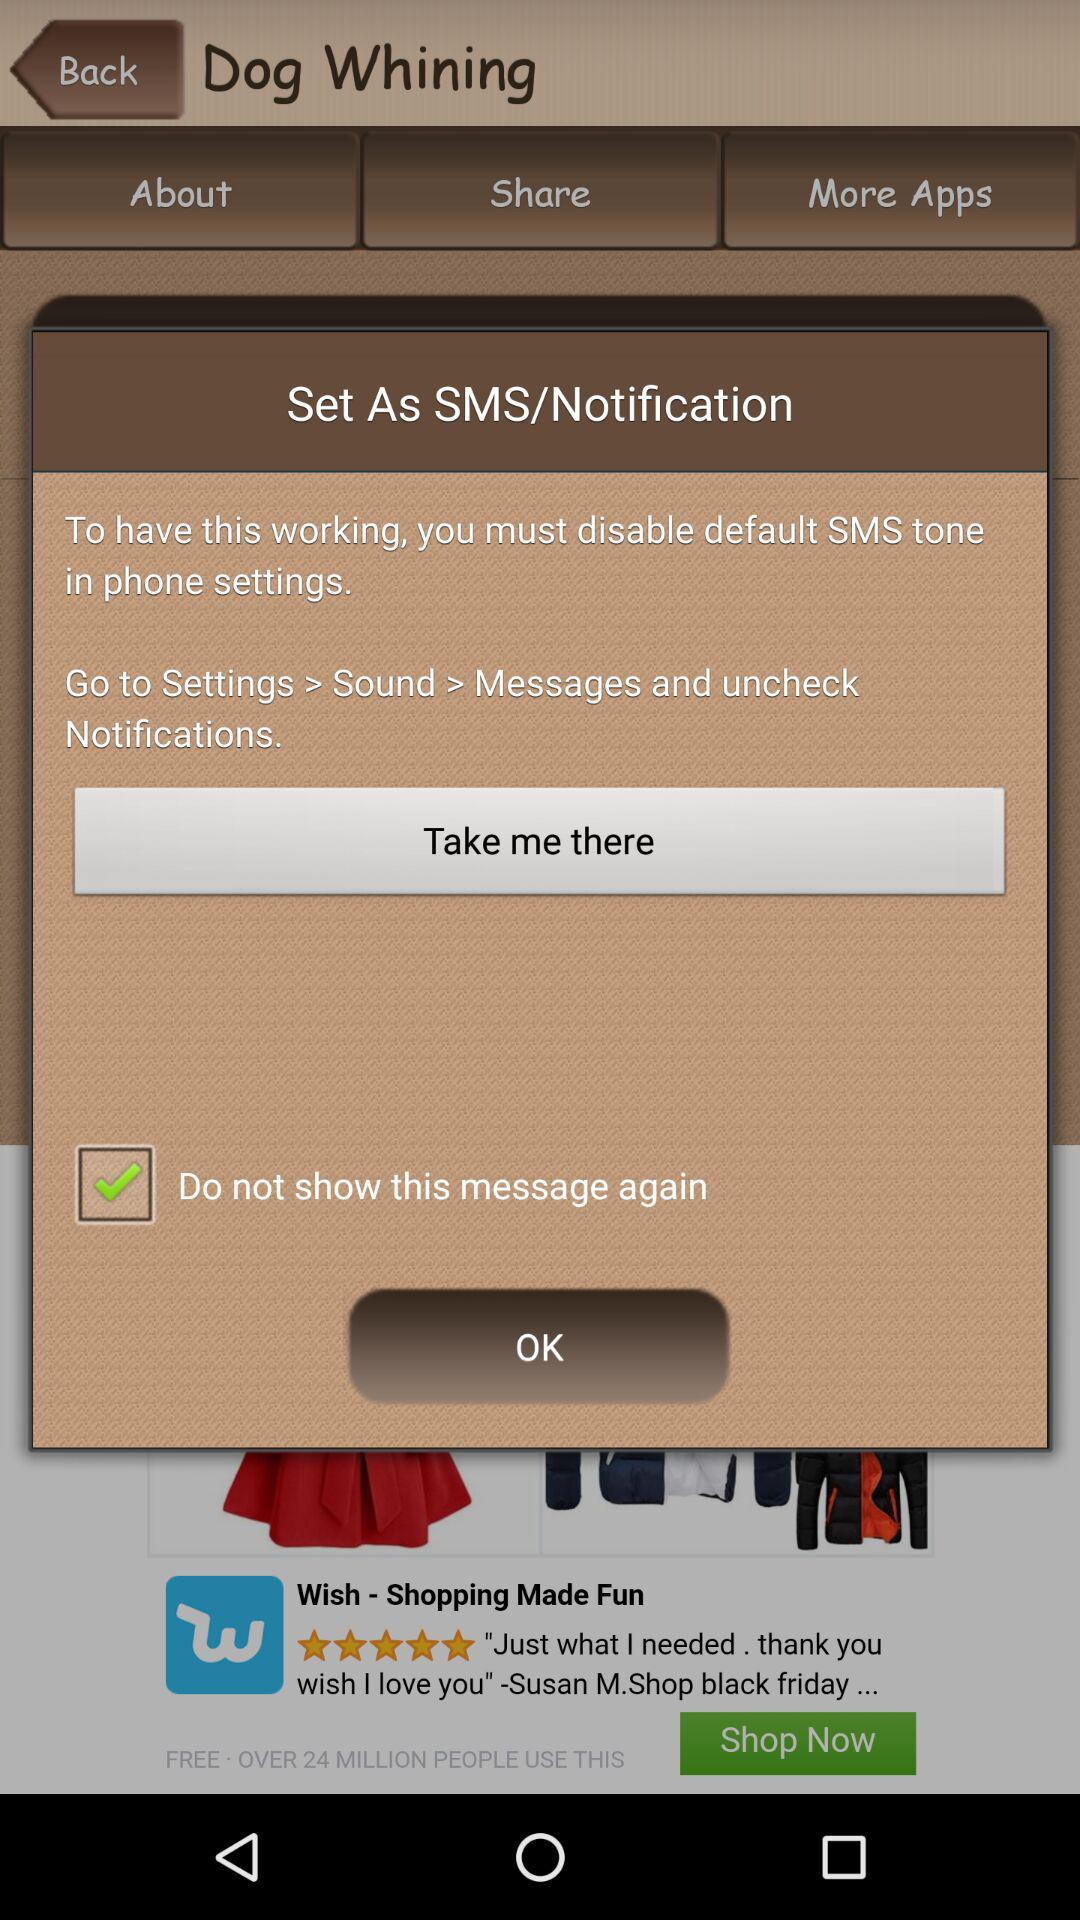How many steps are there to disable default SMS tone?
Answer the question using a single word or phrase. 3 